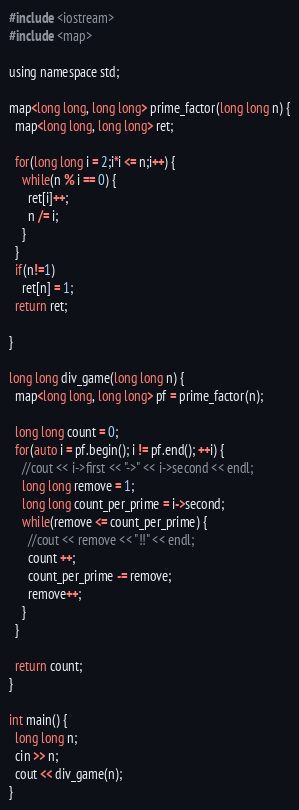Convert code to text. <code><loc_0><loc_0><loc_500><loc_500><_C_>#include <iostream>
#include <map>

using namespace std;

map<long long, long long> prime_factor(long long n) {
  map<long long, long long> ret;

  for(long long i = 2;i*i <= n;i++) {
    while(n % i == 0) {
      ret[i]++;
      n /= i;
    }
  }
  if(n!=1)
    ret[n] = 1;
  return ret;

}

long long div_game(long long n) {
  map<long long, long long> pf = prime_factor(n);

  long long count = 0;
  for(auto i = pf.begin(); i != pf.end(); ++i) {
    //cout << i->first << "->" << i->second << endl;
    long long remove = 1;
    long long count_per_prime = i->second;
    while(remove <= count_per_prime) {
      //cout << remove << "!!" << endl;
      count ++;
      count_per_prime -= remove;
      remove++;
    }
  }

  return count;
}

int main() {
  long long n;
  cin >> n;
  cout << div_game(n);
}</code> 